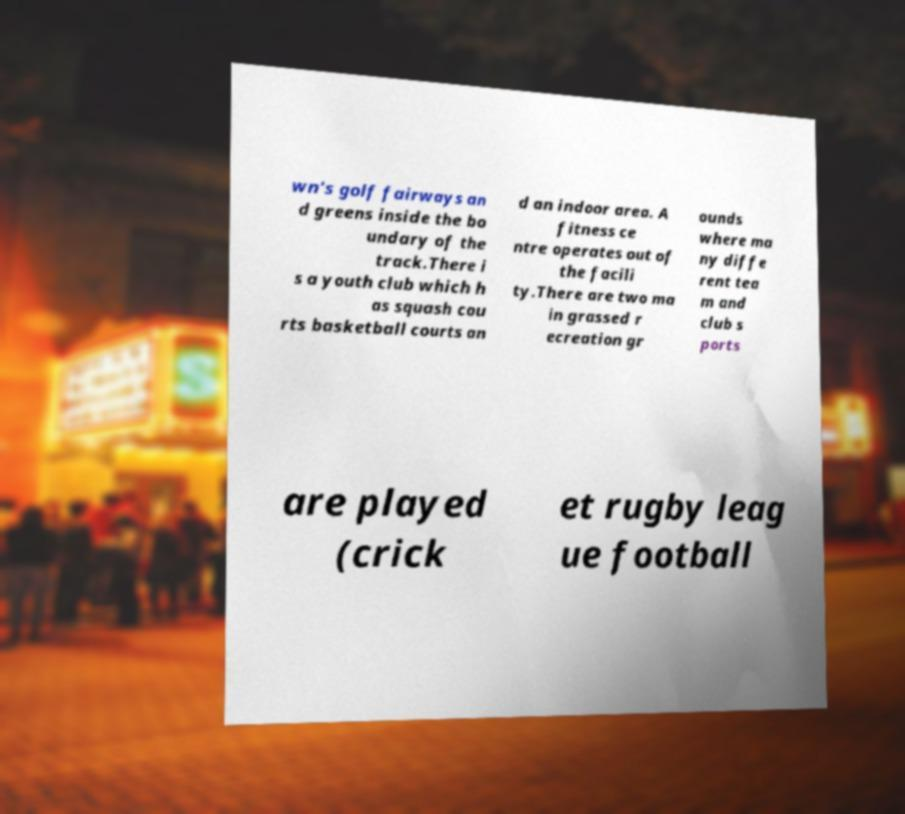Could you extract and type out the text from this image? wn's golf fairways an d greens inside the bo undary of the track.There i s a youth club which h as squash cou rts basketball courts an d an indoor area. A fitness ce ntre operates out of the facili ty.There are two ma in grassed r ecreation gr ounds where ma ny diffe rent tea m and club s ports are played (crick et rugby leag ue football 